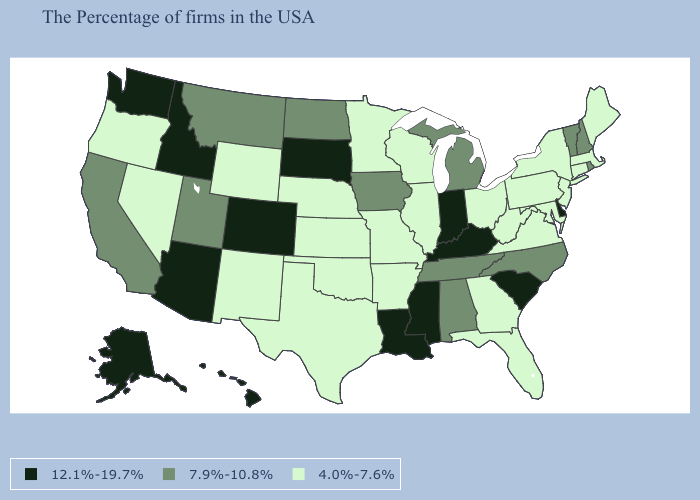What is the value of Missouri?
Write a very short answer. 4.0%-7.6%. Among the states that border Arkansas , does Missouri have the highest value?
Quick response, please. No. What is the value of Rhode Island?
Answer briefly. 7.9%-10.8%. Name the states that have a value in the range 7.9%-10.8%?
Write a very short answer. Rhode Island, New Hampshire, Vermont, North Carolina, Michigan, Alabama, Tennessee, Iowa, North Dakota, Utah, Montana, California. Which states have the highest value in the USA?
Short answer required. Delaware, South Carolina, Kentucky, Indiana, Mississippi, Louisiana, South Dakota, Colorado, Arizona, Idaho, Washington, Alaska, Hawaii. Name the states that have a value in the range 12.1%-19.7%?
Concise answer only. Delaware, South Carolina, Kentucky, Indiana, Mississippi, Louisiana, South Dakota, Colorado, Arizona, Idaho, Washington, Alaska, Hawaii. Among the states that border Louisiana , does Mississippi have the lowest value?
Be succinct. No. What is the highest value in the USA?
Write a very short answer. 12.1%-19.7%. What is the value of Virginia?
Quick response, please. 4.0%-7.6%. What is the lowest value in the USA?
Answer briefly. 4.0%-7.6%. Name the states that have a value in the range 12.1%-19.7%?
Keep it brief. Delaware, South Carolina, Kentucky, Indiana, Mississippi, Louisiana, South Dakota, Colorado, Arizona, Idaho, Washington, Alaska, Hawaii. Does the map have missing data?
Short answer required. No. Name the states that have a value in the range 12.1%-19.7%?
Quick response, please. Delaware, South Carolina, Kentucky, Indiana, Mississippi, Louisiana, South Dakota, Colorado, Arizona, Idaho, Washington, Alaska, Hawaii. Does South Carolina have the lowest value in the South?
Write a very short answer. No. Does Arizona have the lowest value in the USA?
Be succinct. No. 